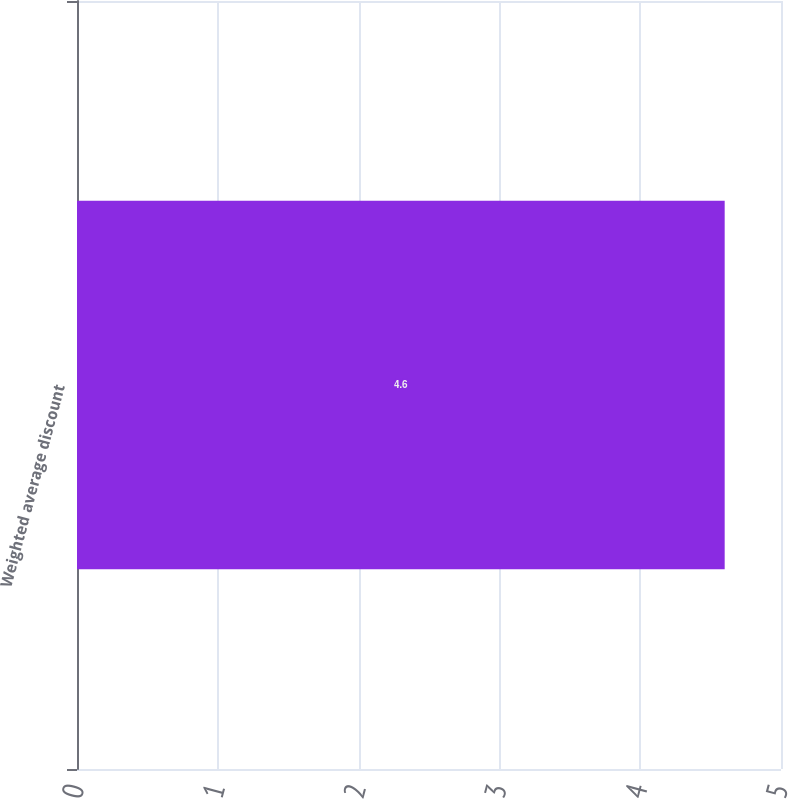Convert chart to OTSL. <chart><loc_0><loc_0><loc_500><loc_500><bar_chart><fcel>Weighted average discount<nl><fcel>4.6<nl></chart> 